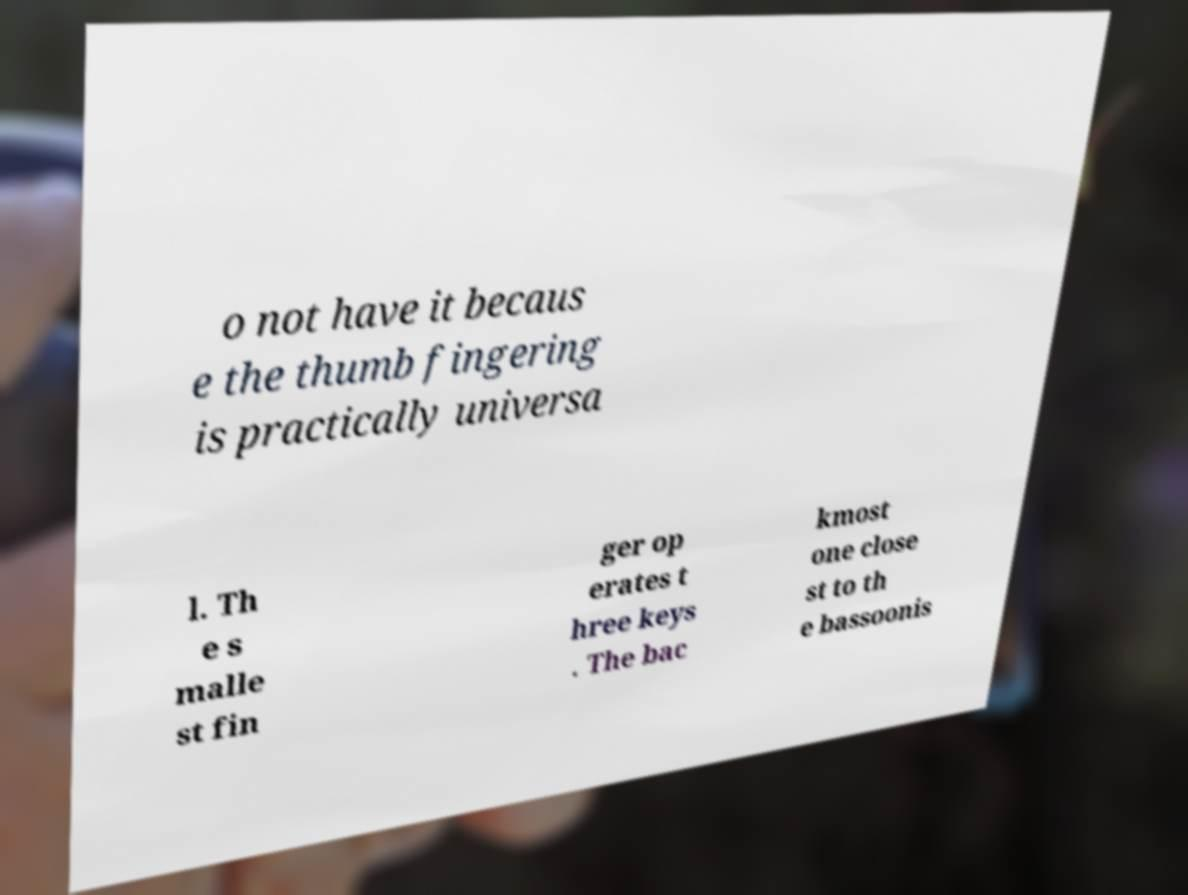For documentation purposes, I need the text within this image transcribed. Could you provide that? o not have it becaus e the thumb fingering is practically universa l. Th e s malle st fin ger op erates t hree keys . The bac kmost one close st to th e bassoonis 